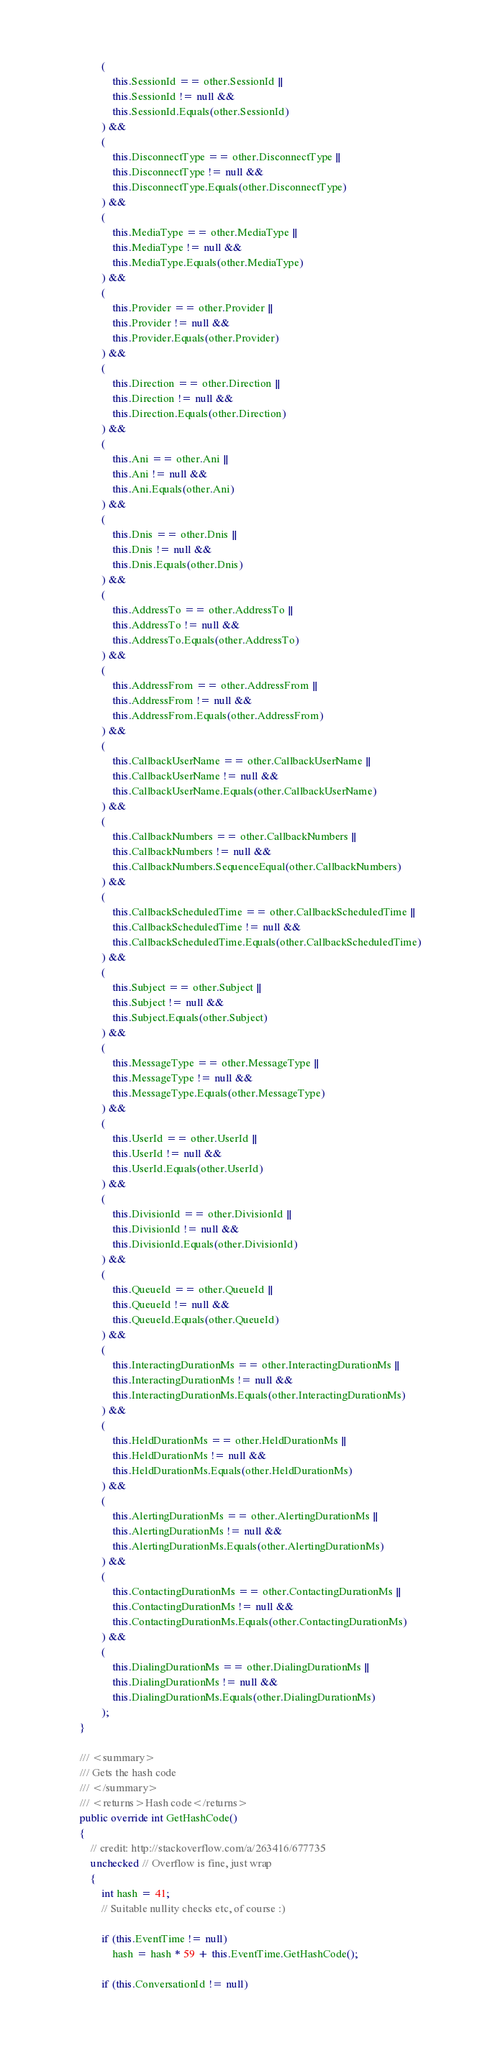<code> <loc_0><loc_0><loc_500><loc_500><_C#_>                (
                    this.SessionId == other.SessionId ||
                    this.SessionId != null &&
                    this.SessionId.Equals(other.SessionId)
                ) &&
                (
                    this.DisconnectType == other.DisconnectType ||
                    this.DisconnectType != null &&
                    this.DisconnectType.Equals(other.DisconnectType)
                ) &&
                (
                    this.MediaType == other.MediaType ||
                    this.MediaType != null &&
                    this.MediaType.Equals(other.MediaType)
                ) &&
                (
                    this.Provider == other.Provider ||
                    this.Provider != null &&
                    this.Provider.Equals(other.Provider)
                ) &&
                (
                    this.Direction == other.Direction ||
                    this.Direction != null &&
                    this.Direction.Equals(other.Direction)
                ) &&
                (
                    this.Ani == other.Ani ||
                    this.Ani != null &&
                    this.Ani.Equals(other.Ani)
                ) &&
                (
                    this.Dnis == other.Dnis ||
                    this.Dnis != null &&
                    this.Dnis.Equals(other.Dnis)
                ) &&
                (
                    this.AddressTo == other.AddressTo ||
                    this.AddressTo != null &&
                    this.AddressTo.Equals(other.AddressTo)
                ) &&
                (
                    this.AddressFrom == other.AddressFrom ||
                    this.AddressFrom != null &&
                    this.AddressFrom.Equals(other.AddressFrom)
                ) &&
                (
                    this.CallbackUserName == other.CallbackUserName ||
                    this.CallbackUserName != null &&
                    this.CallbackUserName.Equals(other.CallbackUserName)
                ) &&
                (
                    this.CallbackNumbers == other.CallbackNumbers ||
                    this.CallbackNumbers != null &&
                    this.CallbackNumbers.SequenceEqual(other.CallbackNumbers)
                ) &&
                (
                    this.CallbackScheduledTime == other.CallbackScheduledTime ||
                    this.CallbackScheduledTime != null &&
                    this.CallbackScheduledTime.Equals(other.CallbackScheduledTime)
                ) &&
                (
                    this.Subject == other.Subject ||
                    this.Subject != null &&
                    this.Subject.Equals(other.Subject)
                ) &&
                (
                    this.MessageType == other.MessageType ||
                    this.MessageType != null &&
                    this.MessageType.Equals(other.MessageType)
                ) &&
                (
                    this.UserId == other.UserId ||
                    this.UserId != null &&
                    this.UserId.Equals(other.UserId)
                ) &&
                (
                    this.DivisionId == other.DivisionId ||
                    this.DivisionId != null &&
                    this.DivisionId.Equals(other.DivisionId)
                ) &&
                (
                    this.QueueId == other.QueueId ||
                    this.QueueId != null &&
                    this.QueueId.Equals(other.QueueId)
                ) &&
                (
                    this.InteractingDurationMs == other.InteractingDurationMs ||
                    this.InteractingDurationMs != null &&
                    this.InteractingDurationMs.Equals(other.InteractingDurationMs)
                ) &&
                (
                    this.HeldDurationMs == other.HeldDurationMs ||
                    this.HeldDurationMs != null &&
                    this.HeldDurationMs.Equals(other.HeldDurationMs)
                ) &&
                (
                    this.AlertingDurationMs == other.AlertingDurationMs ||
                    this.AlertingDurationMs != null &&
                    this.AlertingDurationMs.Equals(other.AlertingDurationMs)
                ) &&
                (
                    this.ContactingDurationMs == other.ContactingDurationMs ||
                    this.ContactingDurationMs != null &&
                    this.ContactingDurationMs.Equals(other.ContactingDurationMs)
                ) &&
                (
                    this.DialingDurationMs == other.DialingDurationMs ||
                    this.DialingDurationMs != null &&
                    this.DialingDurationMs.Equals(other.DialingDurationMs)
                );
        }

        /// <summary>
        /// Gets the hash code
        /// </summary>
        /// <returns>Hash code</returns>
        public override int GetHashCode()
        {
            // credit: http://stackoverflow.com/a/263416/677735
            unchecked // Overflow is fine, just wrap
            {
                int hash = 41;
                // Suitable nullity checks etc, of course :)
                
                if (this.EventTime != null)
                    hash = hash * 59 + this.EventTime.GetHashCode();
                
                if (this.ConversationId != null)</code> 